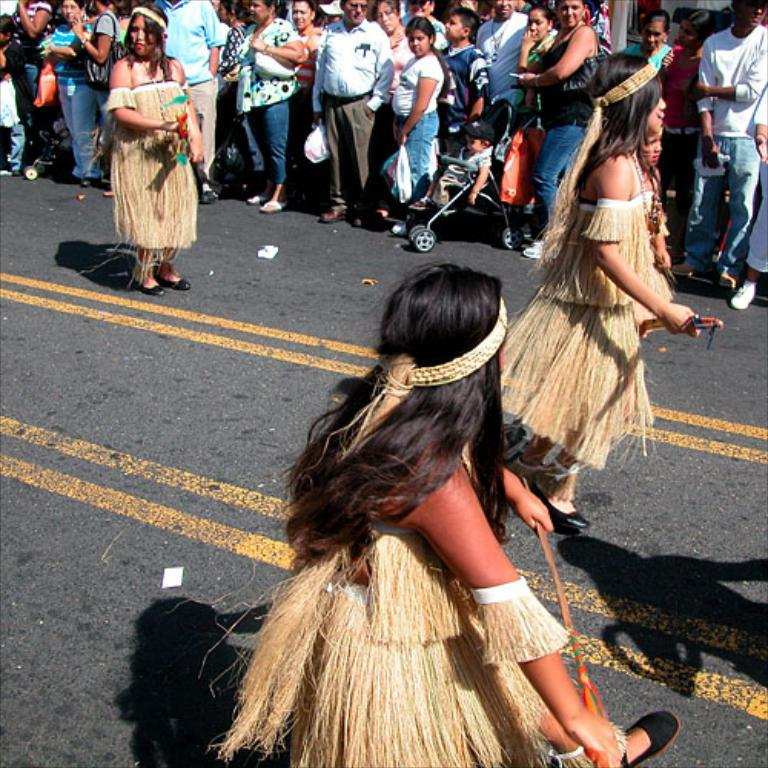What is the main activity taking place in the image? Many people are gathered in the image, and they are watching something. Can you describe the specific actions of some individuals in the image? There are three women dancing on the road. What type of poison is being used by the aunt in the image? There is no aunt or poison present in the image. 